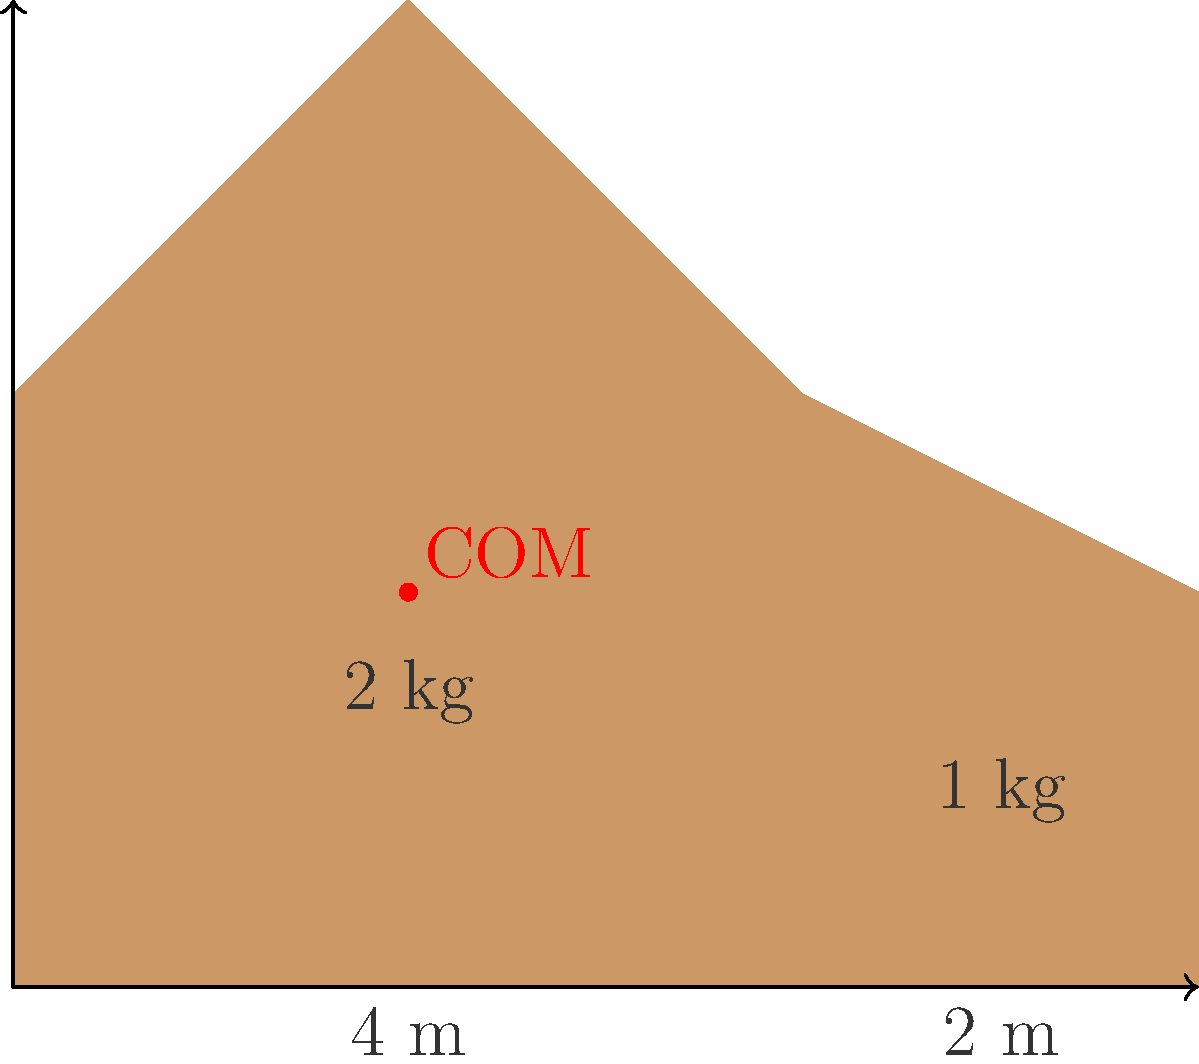A public art installation consists of two connected asymmetrical pieces: a larger pentagonal piece weighing 2 kg and a smaller quadrilateral piece weighing 1 kg. The base of the entire installation is 6 meters long, with the larger piece occupying the first 4 meters. Calculate the x-coordinate of the center of mass of the entire installation, assuming the center of mass of each piece is at its geometric center. To find the center of mass of the entire installation, we need to follow these steps:

1. Determine the x-coordinates of the center of mass for each piece:
   - Larger piece (2 kg): $x_1 = 2$ m (midpoint of its 4 m base)
   - Smaller piece (1 kg): $x_2 = 5$ m (midpoint of its 2 m base)

2. Use the formula for the center of mass of a system:
   $$x_{COM} = \frac{m_1x_1 + m_2x_2}{m_1 + m_2}$$
   
   Where:
   $x_{COM}$ is the x-coordinate of the center of mass of the entire system
   $m_1$ and $m_2$ are the masses of the two pieces
   $x_1$ and $x_2$ are the x-coordinates of the centers of mass of each piece

3. Substitute the values:
   $$x_{COM} = \frac{(2 \text{ kg})(2 \text{ m}) + (1 \text{ kg})(5 \text{ m})}{2 \text{ kg} + 1 \text{ kg}}$$

4. Calculate:
   $$x_{COM} = \frac{4 \text{ kg}\cdot\text{m} + 5 \text{ kg}\cdot\text{m}}{3 \text{ kg}} = \frac{9 \text{ kg}\cdot\text{m}}{3 \text{ kg}} = 3 \text{ m}$$

Therefore, the x-coordinate of the center of mass of the entire installation is 3 meters from the left edge.
Answer: 3 m 